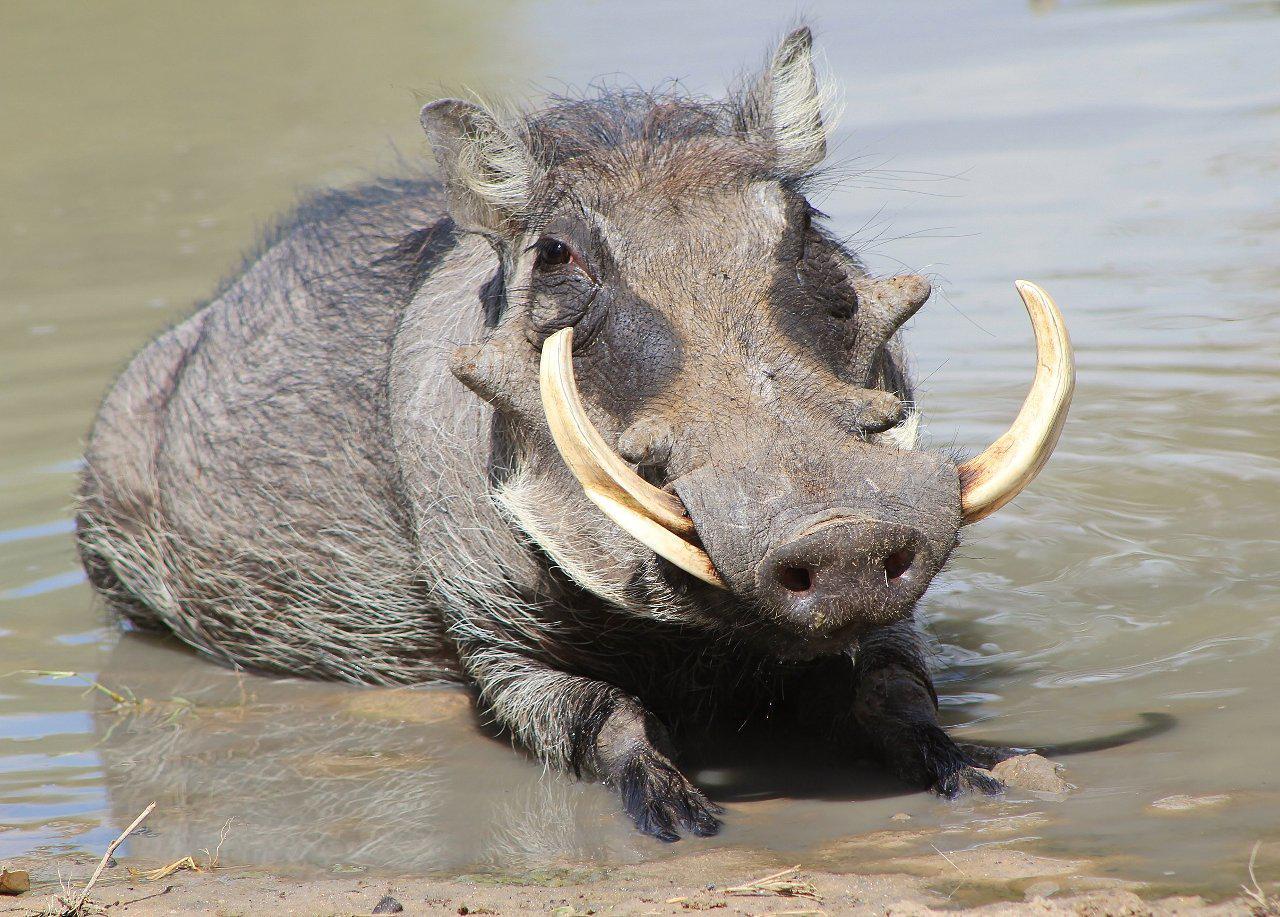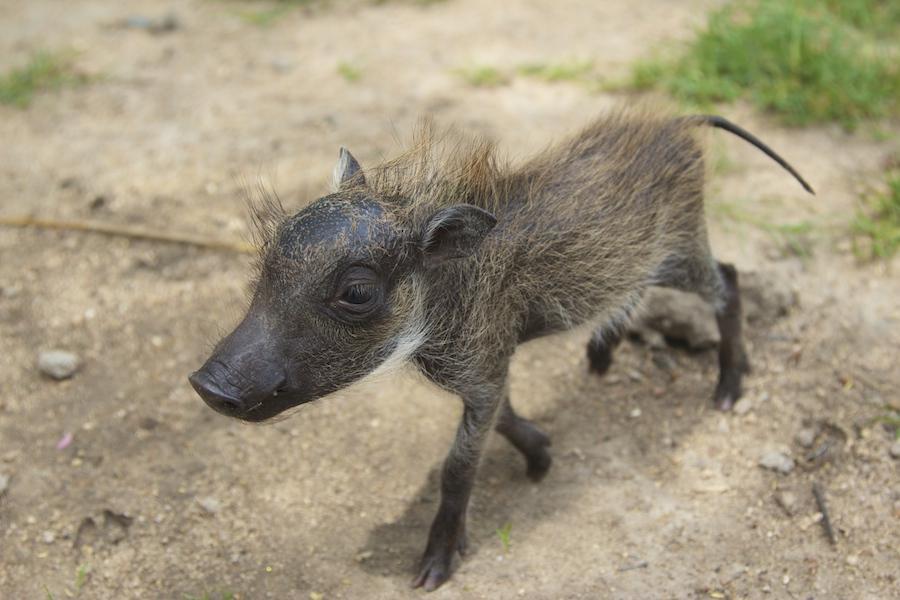The first image is the image on the left, the second image is the image on the right. For the images displayed, is the sentence "One image contains more than one warthog." factually correct? Answer yes or no. No. The first image is the image on the left, the second image is the image on the right. Evaluate the accuracy of this statement regarding the images: "We see a baby warthog in one of the images.". Is it true? Answer yes or no. Yes. 